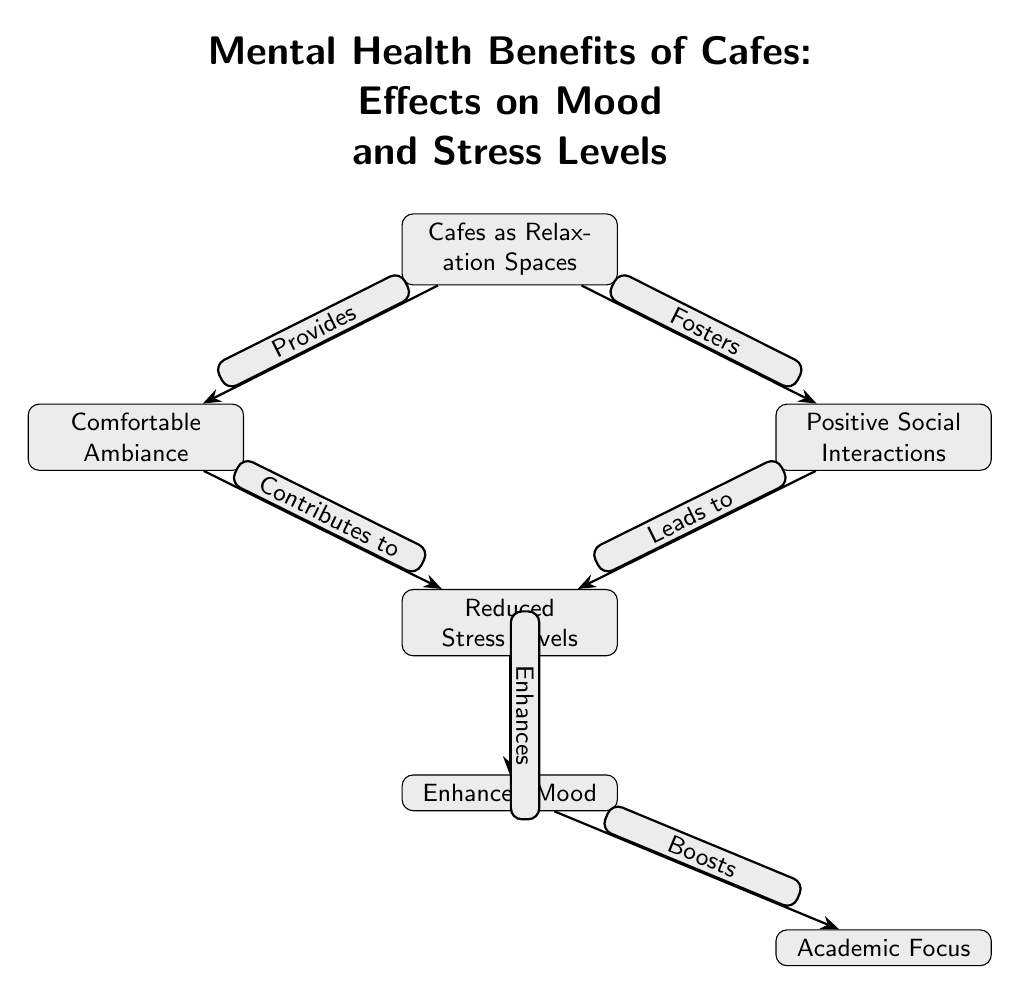What is the main topic of the diagram? The title of the diagram explicitly states that it is about the mental health benefits of cafes, focusing on their effects on mood and stress levels.
Answer: Mental Health Benefits of Cafes: Effects on Mood and Stress Levels How many nodes are present in the diagram? By counting all the individual blocks (nodes) displayed in the diagram, we find there are a total of six nodes.
Answer: 6 What leads to reduced stress levels? The diagram shows that both positive social interactions and a comfortable ambiance foster reduced stress levels, indicated by the arrows from these nodes to the reduced stress levels node.
Answer: Positive Social Interactions, Comfortable Ambiance What enhances mood according to the diagram? The arrow pointing from "Reduced Stress Levels" to "Enhanced Mood" indicates that reduced stress levels directly enhance mood; therefore, this relationship is visualized through this connection.
Answer: Reduced Stress Levels How do enhanced moods affect academic focus? The diagram indicates that enhanced mood boosts academic focus, as shown by the directional flow from the "Enhanced Mood" node to the "Academic Focus" node.
Answer: Boosts What two factors contribute to reduced stress levels? The diagram shows that both positive social interactions and comfortable ambiance contribute to reduced stress levels, as represented by arrows leading to the reduced stress levels node.
Answer: Positive Social Interactions, Comfortable Ambiance Which node is at the highest position? The highest node in the diagram, from which other nodes are derived, is "Cafes as Relaxation Spaces," indicating its central role in the diagram's conclusions about benefits.
Answer: Cafes as Relaxation Spaces What is the relationship between comfortable ambiance and stress levels? According to the diagram, the comfortable ambiance directly contributes to reducing stress levels, indicated by the directed edge connecting these two nodes.
Answer: Contributes to What effect does positive social interaction have on stress levels? The diagram illustrates that positive social interactions lead to reduced stress levels, evidenced by the directed arrow from the social interactions node to the stress levels node.
Answer: Leads to 